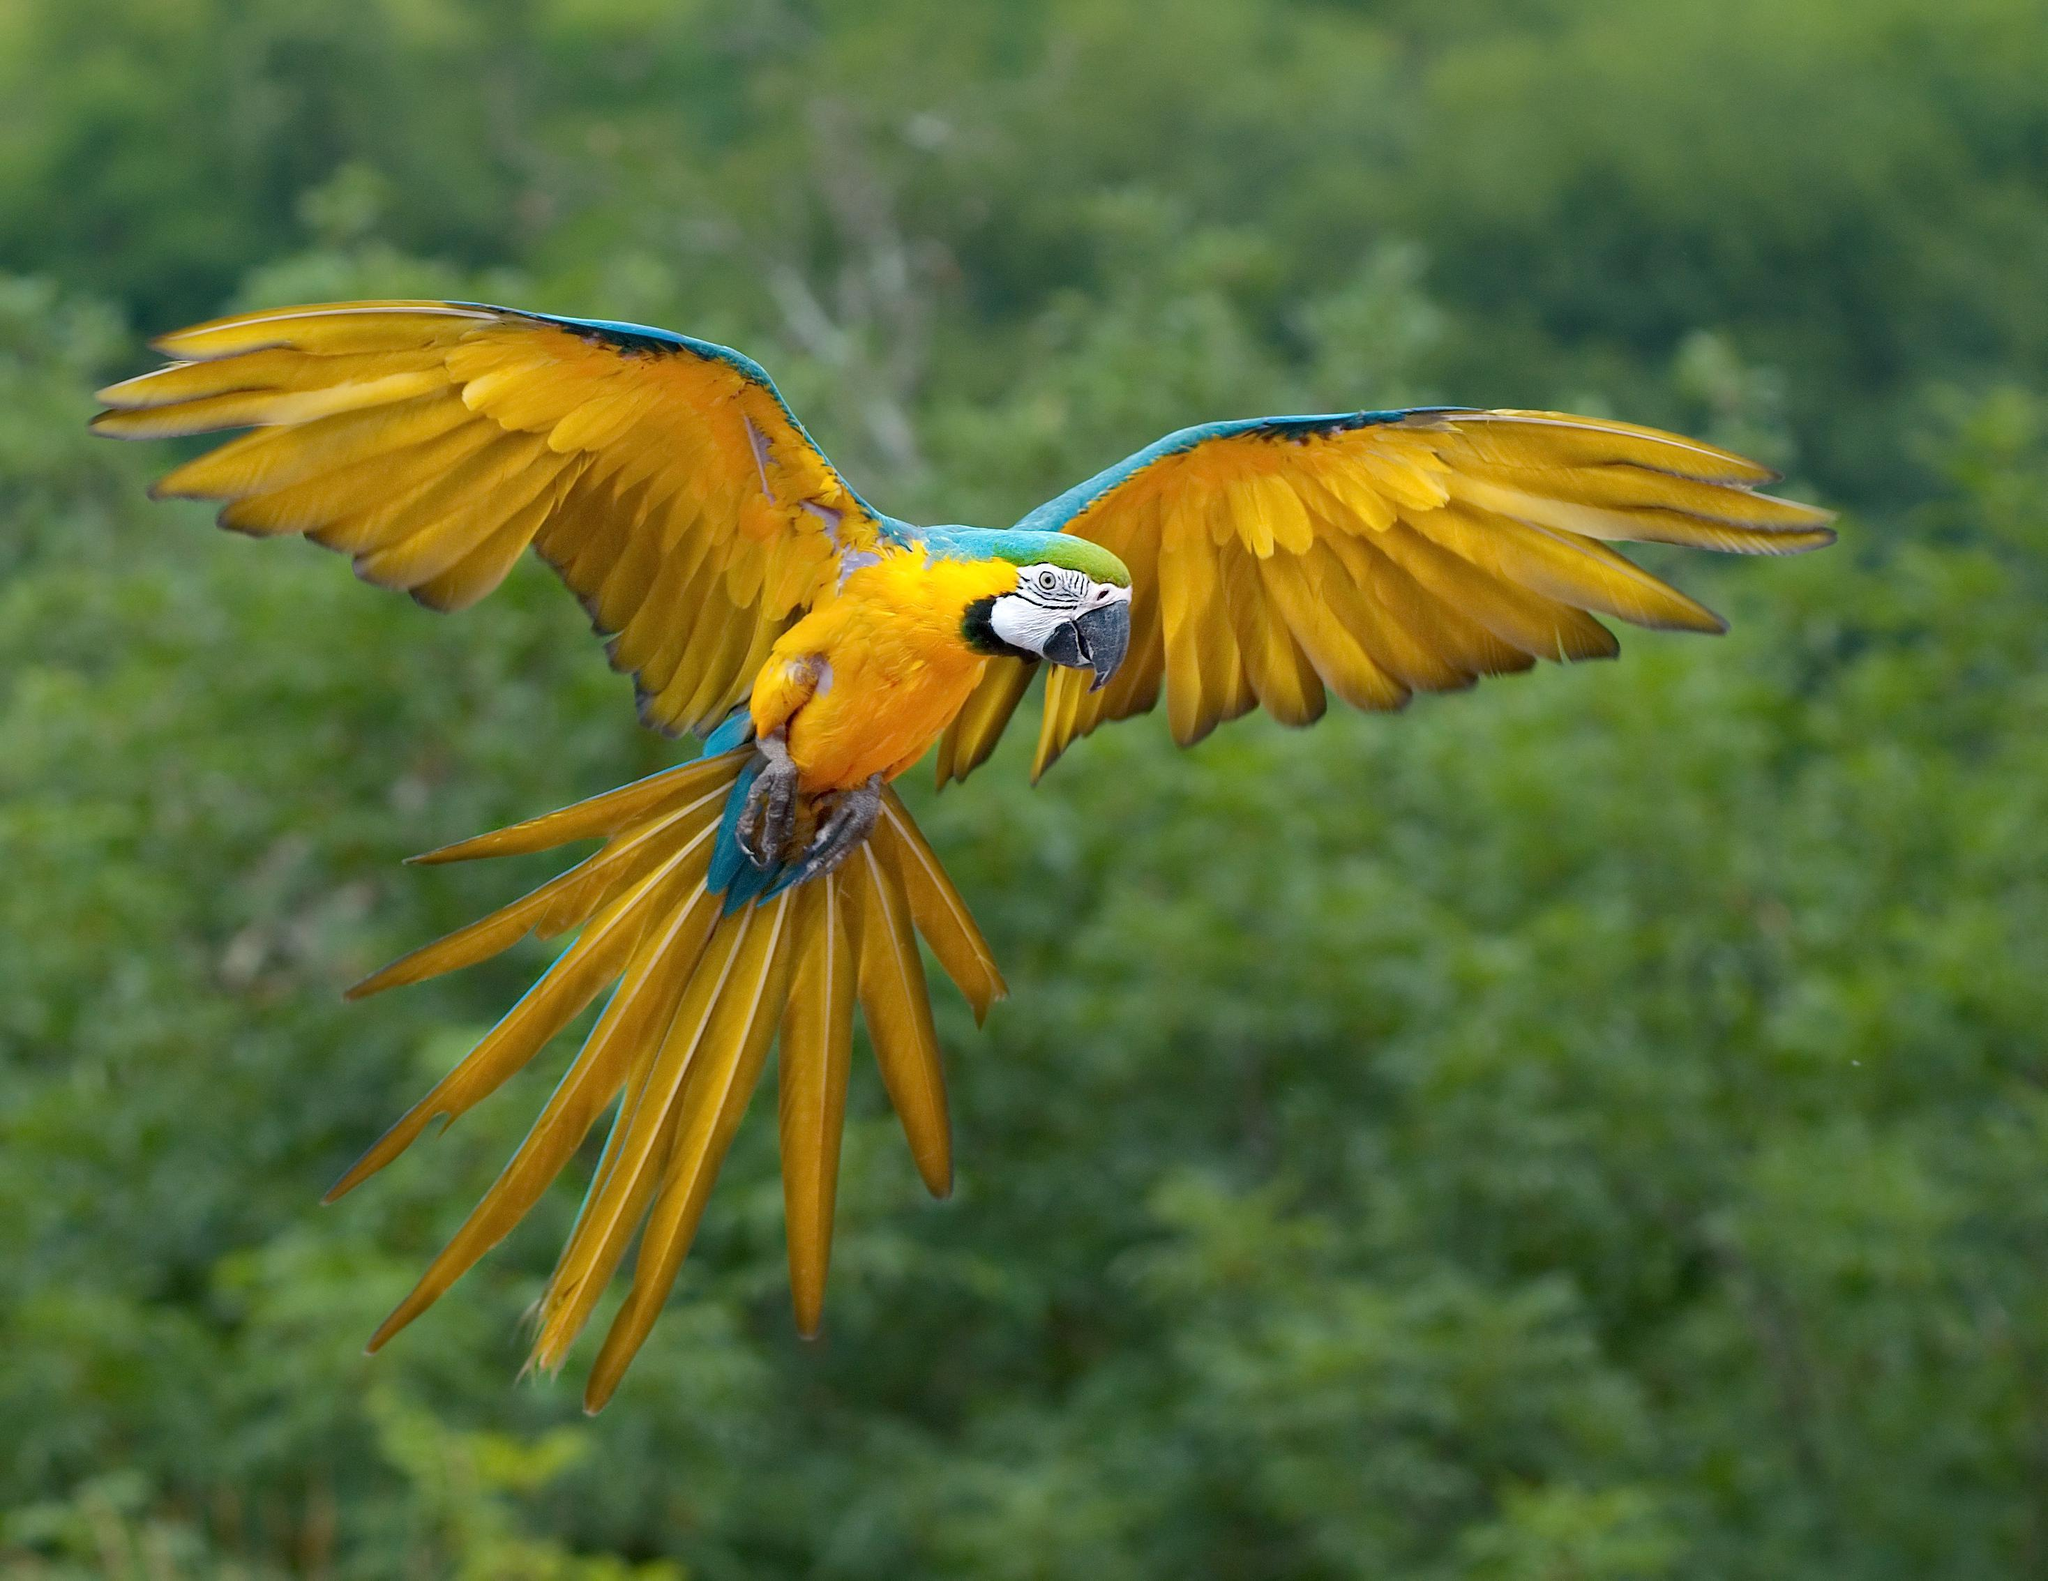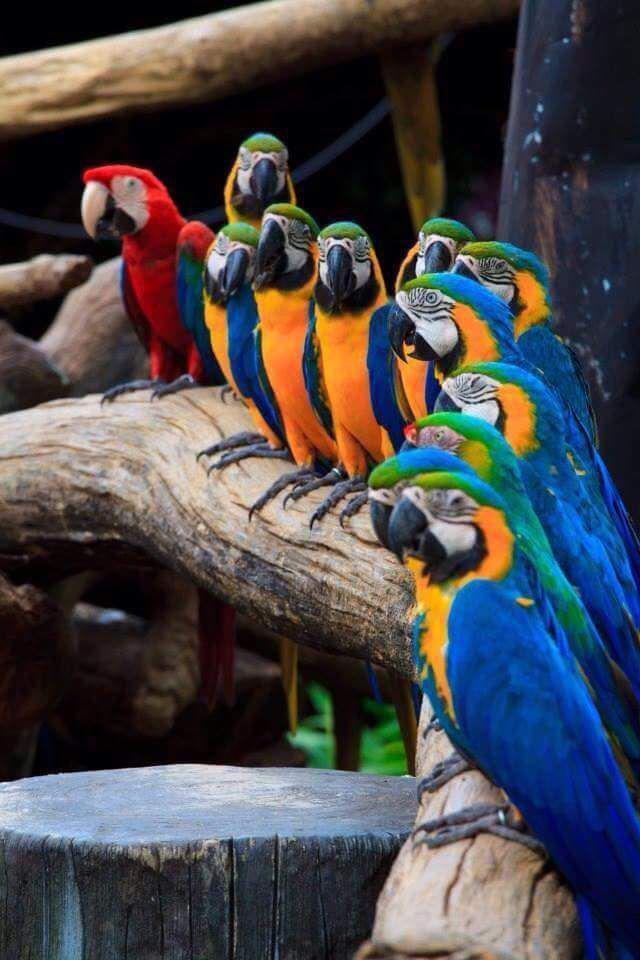The first image is the image on the left, the second image is the image on the right. Evaluate the accuracy of this statement regarding the images: "There are at least four birds in the image on the right.". Is it true? Answer yes or no. Yes. 